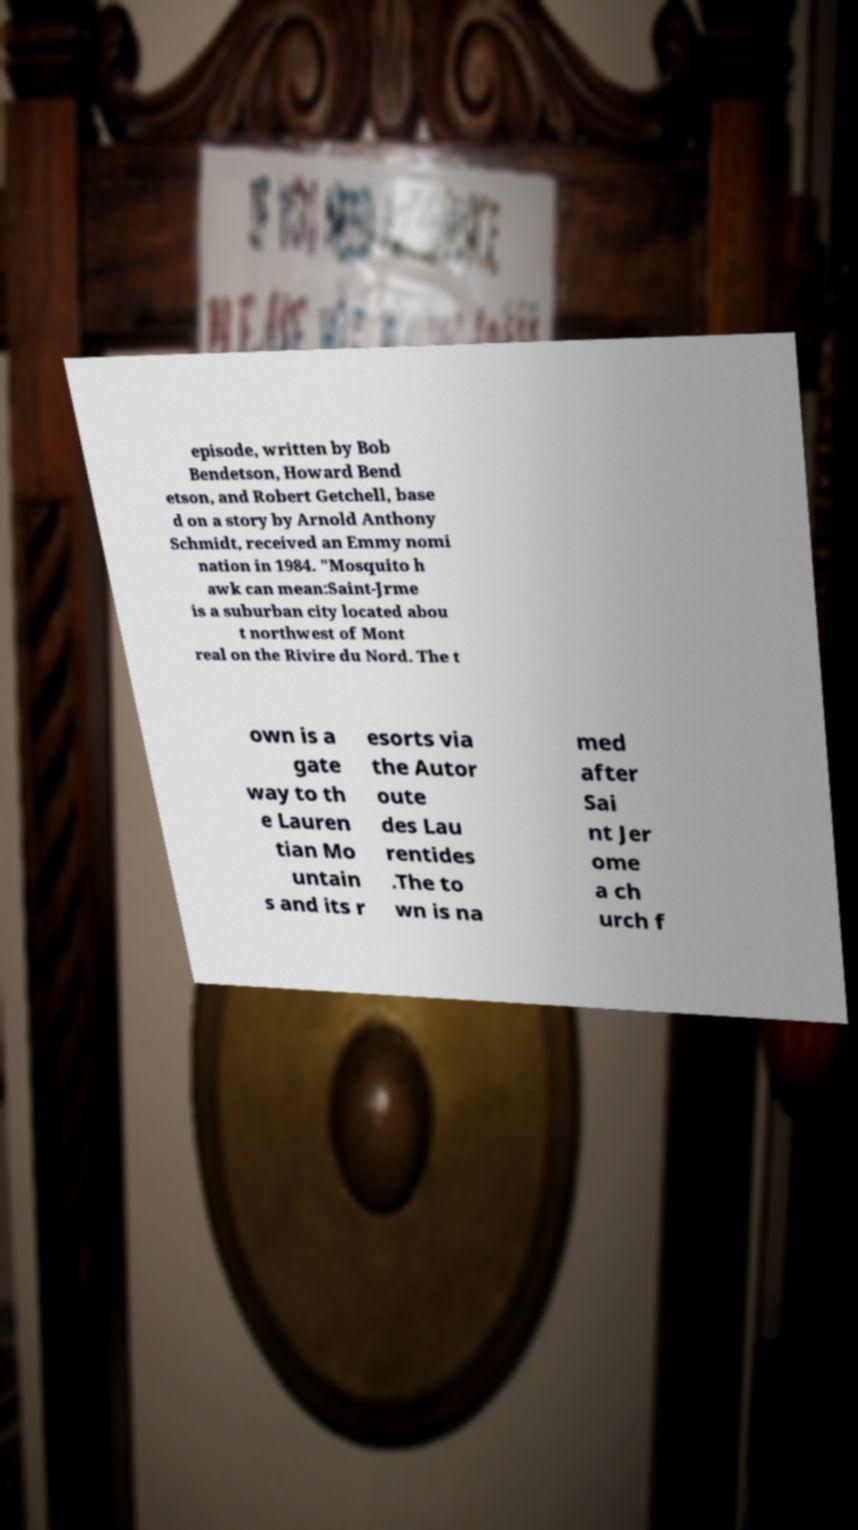Could you extract and type out the text from this image? episode, written by Bob Bendetson, Howard Bend etson, and Robert Getchell, base d on a story by Arnold Anthony Schmidt, received an Emmy nomi nation in 1984. "Mosquito h awk can mean:Saint-Jrme is a suburban city located abou t northwest of Mont real on the Rivire du Nord. The t own is a gate way to th e Lauren tian Mo untain s and its r esorts via the Autor oute des Lau rentides .The to wn is na med after Sai nt Jer ome a ch urch f 